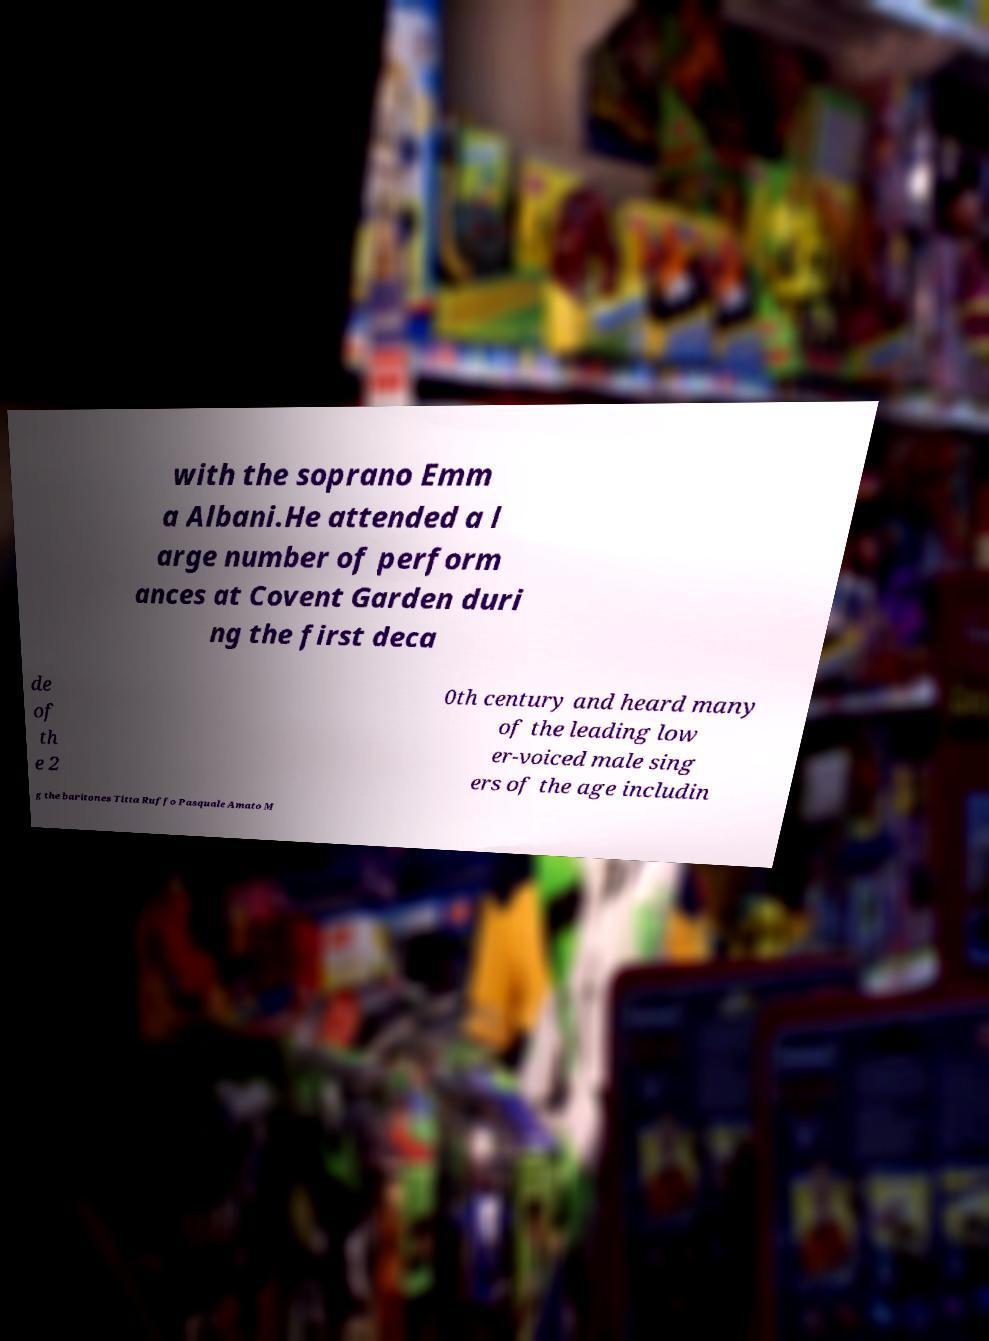Please read and relay the text visible in this image. What does it say? with the soprano Emm a Albani.He attended a l arge number of perform ances at Covent Garden duri ng the first deca de of th e 2 0th century and heard many of the leading low er-voiced male sing ers of the age includin g the baritones Titta Ruffo Pasquale Amato M 